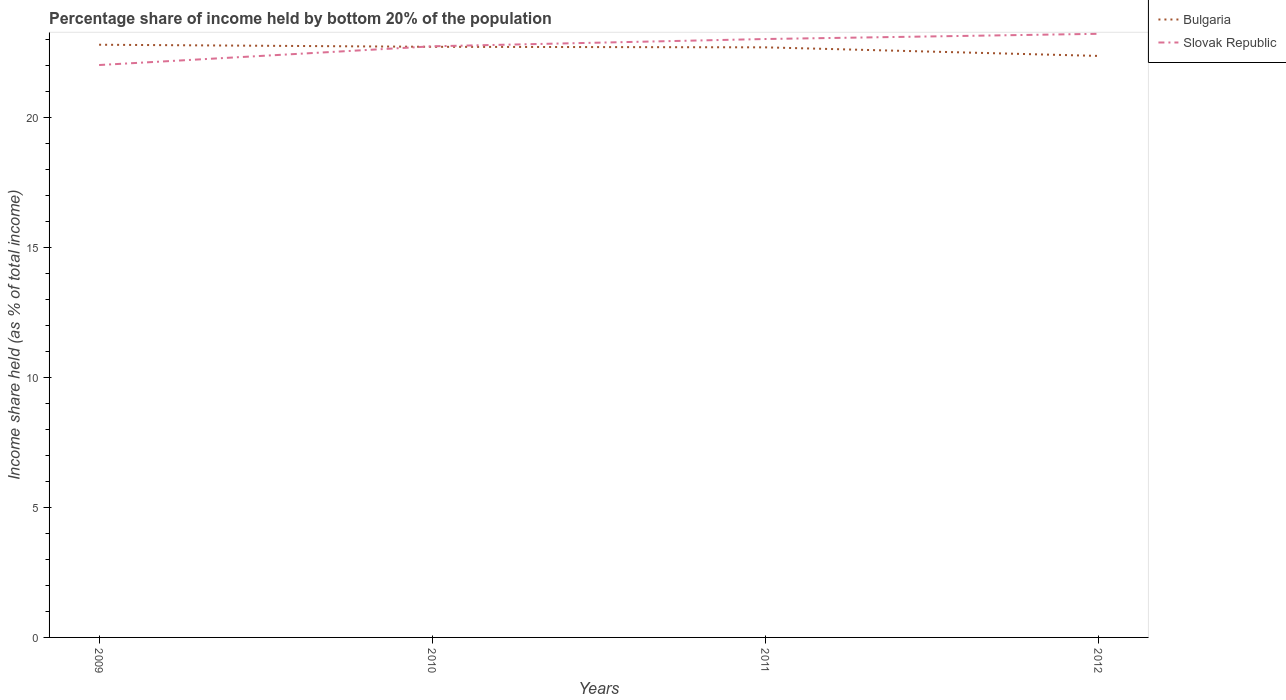How many different coloured lines are there?
Provide a short and direct response. 2. Does the line corresponding to Bulgaria intersect with the line corresponding to Slovak Republic?
Ensure brevity in your answer.  Yes. Is the number of lines equal to the number of legend labels?
Make the answer very short. Yes. Across all years, what is the maximum share of income held by bottom 20% of the population in Bulgaria?
Your answer should be compact. 22.35. What is the total share of income held by bottom 20% of the population in Slovak Republic in the graph?
Make the answer very short. -1. What is the difference between the highest and the second highest share of income held by bottom 20% of the population in Bulgaria?
Provide a succinct answer. 0.43. How many lines are there?
Provide a short and direct response. 2. How many years are there in the graph?
Provide a short and direct response. 4. Does the graph contain any zero values?
Provide a succinct answer. No. How are the legend labels stacked?
Ensure brevity in your answer.  Vertical. What is the title of the graph?
Offer a very short reply. Percentage share of income held by bottom 20% of the population. What is the label or title of the Y-axis?
Provide a succinct answer. Income share held (as % of total income). What is the Income share held (as % of total income) of Bulgaria in 2009?
Ensure brevity in your answer.  22.78. What is the Income share held (as % of total income) in Bulgaria in 2010?
Your answer should be very brief. 22.7. What is the Income share held (as % of total income) in Slovak Republic in 2010?
Provide a short and direct response. 22.72. What is the Income share held (as % of total income) in Bulgaria in 2011?
Your answer should be very brief. 22.68. What is the Income share held (as % of total income) in Slovak Republic in 2011?
Keep it short and to the point. 23. What is the Income share held (as % of total income) of Bulgaria in 2012?
Your answer should be compact. 22.35. What is the Income share held (as % of total income) of Slovak Republic in 2012?
Ensure brevity in your answer.  23.2. Across all years, what is the maximum Income share held (as % of total income) of Bulgaria?
Make the answer very short. 22.78. Across all years, what is the maximum Income share held (as % of total income) in Slovak Republic?
Your response must be concise. 23.2. Across all years, what is the minimum Income share held (as % of total income) in Bulgaria?
Your answer should be compact. 22.35. Across all years, what is the minimum Income share held (as % of total income) in Slovak Republic?
Provide a succinct answer. 22. What is the total Income share held (as % of total income) of Bulgaria in the graph?
Your answer should be compact. 90.51. What is the total Income share held (as % of total income) in Slovak Republic in the graph?
Your answer should be very brief. 90.92. What is the difference between the Income share held (as % of total income) in Bulgaria in 2009 and that in 2010?
Offer a terse response. 0.08. What is the difference between the Income share held (as % of total income) in Slovak Republic in 2009 and that in 2010?
Provide a short and direct response. -0.72. What is the difference between the Income share held (as % of total income) of Slovak Republic in 2009 and that in 2011?
Your response must be concise. -1. What is the difference between the Income share held (as % of total income) of Bulgaria in 2009 and that in 2012?
Provide a succinct answer. 0.43. What is the difference between the Income share held (as % of total income) in Slovak Republic in 2009 and that in 2012?
Keep it short and to the point. -1.2. What is the difference between the Income share held (as % of total income) in Slovak Republic in 2010 and that in 2011?
Offer a terse response. -0.28. What is the difference between the Income share held (as % of total income) in Bulgaria in 2010 and that in 2012?
Offer a terse response. 0.35. What is the difference between the Income share held (as % of total income) in Slovak Republic in 2010 and that in 2012?
Offer a terse response. -0.48. What is the difference between the Income share held (as % of total income) of Bulgaria in 2011 and that in 2012?
Ensure brevity in your answer.  0.33. What is the difference between the Income share held (as % of total income) in Bulgaria in 2009 and the Income share held (as % of total income) in Slovak Republic in 2011?
Ensure brevity in your answer.  -0.22. What is the difference between the Income share held (as % of total income) of Bulgaria in 2009 and the Income share held (as % of total income) of Slovak Republic in 2012?
Provide a succinct answer. -0.42. What is the difference between the Income share held (as % of total income) of Bulgaria in 2010 and the Income share held (as % of total income) of Slovak Republic in 2011?
Your response must be concise. -0.3. What is the difference between the Income share held (as % of total income) of Bulgaria in 2011 and the Income share held (as % of total income) of Slovak Republic in 2012?
Your response must be concise. -0.52. What is the average Income share held (as % of total income) in Bulgaria per year?
Offer a terse response. 22.63. What is the average Income share held (as % of total income) in Slovak Republic per year?
Make the answer very short. 22.73. In the year 2009, what is the difference between the Income share held (as % of total income) of Bulgaria and Income share held (as % of total income) of Slovak Republic?
Provide a short and direct response. 0.78. In the year 2010, what is the difference between the Income share held (as % of total income) of Bulgaria and Income share held (as % of total income) of Slovak Republic?
Your answer should be compact. -0.02. In the year 2011, what is the difference between the Income share held (as % of total income) of Bulgaria and Income share held (as % of total income) of Slovak Republic?
Ensure brevity in your answer.  -0.32. In the year 2012, what is the difference between the Income share held (as % of total income) in Bulgaria and Income share held (as % of total income) in Slovak Republic?
Your answer should be very brief. -0.85. What is the ratio of the Income share held (as % of total income) of Bulgaria in 2009 to that in 2010?
Your answer should be compact. 1. What is the ratio of the Income share held (as % of total income) in Slovak Republic in 2009 to that in 2010?
Offer a very short reply. 0.97. What is the ratio of the Income share held (as % of total income) in Bulgaria in 2009 to that in 2011?
Give a very brief answer. 1. What is the ratio of the Income share held (as % of total income) in Slovak Republic in 2009 to that in 2011?
Ensure brevity in your answer.  0.96. What is the ratio of the Income share held (as % of total income) in Bulgaria in 2009 to that in 2012?
Give a very brief answer. 1.02. What is the ratio of the Income share held (as % of total income) in Slovak Republic in 2009 to that in 2012?
Offer a terse response. 0.95. What is the ratio of the Income share held (as % of total income) in Slovak Republic in 2010 to that in 2011?
Provide a succinct answer. 0.99. What is the ratio of the Income share held (as % of total income) of Bulgaria in 2010 to that in 2012?
Give a very brief answer. 1.02. What is the ratio of the Income share held (as % of total income) of Slovak Republic in 2010 to that in 2012?
Keep it short and to the point. 0.98. What is the ratio of the Income share held (as % of total income) in Bulgaria in 2011 to that in 2012?
Your answer should be very brief. 1.01. What is the difference between the highest and the second highest Income share held (as % of total income) of Bulgaria?
Make the answer very short. 0.08. What is the difference between the highest and the second highest Income share held (as % of total income) of Slovak Republic?
Provide a succinct answer. 0.2. What is the difference between the highest and the lowest Income share held (as % of total income) of Bulgaria?
Offer a very short reply. 0.43. What is the difference between the highest and the lowest Income share held (as % of total income) of Slovak Republic?
Your answer should be very brief. 1.2. 